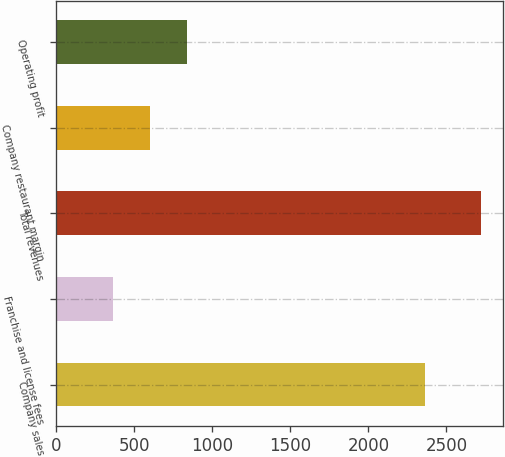Convert chart. <chart><loc_0><loc_0><loc_500><loc_500><bar_chart><fcel>Company sales<fcel>Franchise and license fees<fcel>Total revenues<fcel>Company restaurant margin<fcel>Operating profit<nl><fcel>2360<fcel>365<fcel>2725<fcel>601<fcel>837<nl></chart> 